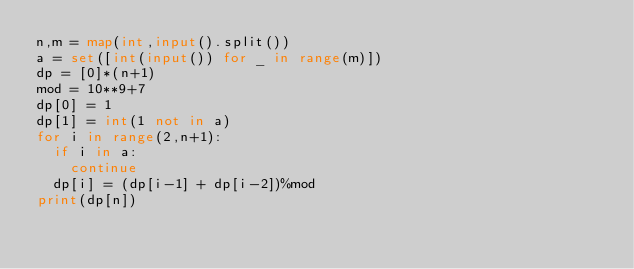Convert code to text. <code><loc_0><loc_0><loc_500><loc_500><_Python_>n,m = map(int,input().split())
a = set([int(input()) for _ in range(m)])
dp = [0]*(n+1)
mod = 10**9+7
dp[0] = 1
dp[1] = int(1 not in a)
for i in range(2,n+1):
  if i in a:
    continue
  dp[i] = (dp[i-1] + dp[i-2])%mod
print(dp[n])
</code> 